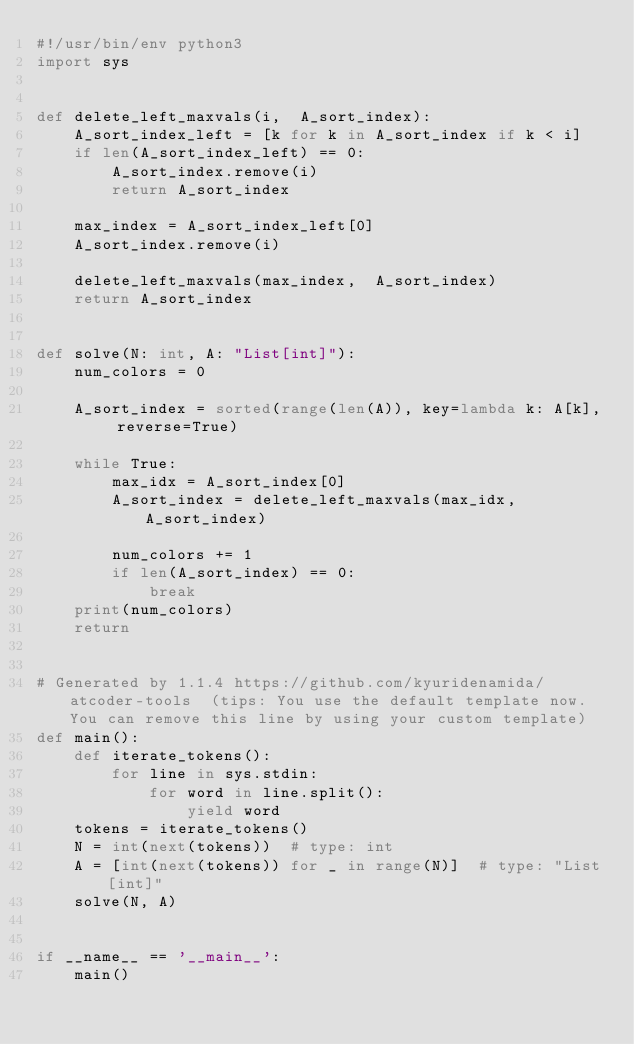<code> <loc_0><loc_0><loc_500><loc_500><_Python_>#!/usr/bin/env python3
import sys


def delete_left_maxvals(i,  A_sort_index):
    A_sort_index_left = [k for k in A_sort_index if k < i]
    if len(A_sort_index_left) == 0:
        A_sort_index.remove(i)
        return A_sort_index
    
    max_index = A_sort_index_left[0]
    A_sort_index.remove(i)

    delete_left_maxvals(max_index,  A_sort_index)
    return A_sort_index


def solve(N: int, A: "List[int]"):
    num_colors = 0

    A_sort_index = sorted(range(len(A)), key=lambda k: A[k], reverse=True)
    
    while True:
        max_idx = A_sort_index[0]
        A_sort_index = delete_left_maxvals(max_idx,  A_sort_index)
        
        num_colors += 1
        if len(A_sort_index) == 0:
            break
    print(num_colors)
    return


# Generated by 1.1.4 https://github.com/kyuridenamida/atcoder-tools  (tips: You use the default template now. You can remove this line by using your custom template)
def main():
    def iterate_tokens():
        for line in sys.stdin:
            for word in line.split():
                yield word
    tokens = iterate_tokens()
    N = int(next(tokens))  # type: int
    A = [int(next(tokens)) for _ in range(N)]  # type: "List[int]"
    solve(N, A)


if __name__ == '__main__':
    main()
</code> 